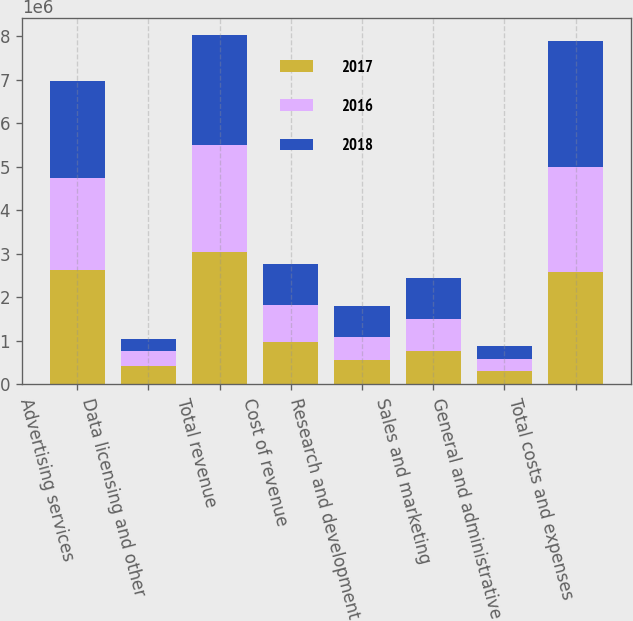Convert chart. <chart><loc_0><loc_0><loc_500><loc_500><stacked_bar_chart><ecel><fcel>Advertising services<fcel>Data licensing and other<fcel>Total revenue<fcel>Cost of revenue<fcel>Research and development<fcel>Sales and marketing<fcel>General and administrative<fcel>Total costs and expenses<nl><fcel>2017<fcel>2.6174e+06<fcel>424962<fcel>3.04236e+06<fcel>964997<fcel>553858<fcel>771361<fcel>298818<fcel>2.58903e+06<nl><fcel>2016<fcel>2.10999e+06<fcel>333312<fcel>2.4433e+06<fcel>861242<fcel>542010<fcel>717419<fcel>283888<fcel>2.40456e+06<nl><fcel>2018<fcel>2.24805e+06<fcel>281567<fcel>2.52962e+06<fcel>932240<fcel>713482<fcel>957829<fcel>293276<fcel>2.89683e+06<nl></chart> 